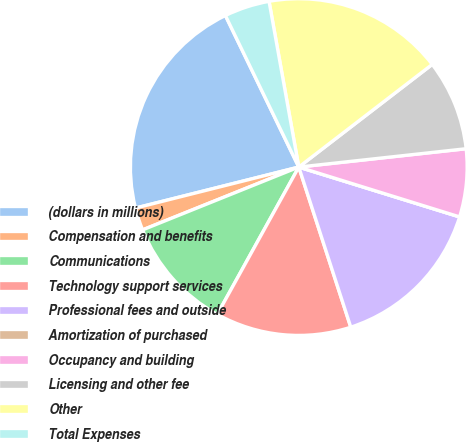Convert chart to OTSL. <chart><loc_0><loc_0><loc_500><loc_500><pie_chart><fcel>(dollars in millions)<fcel>Compensation and benefits<fcel>Communications<fcel>Technology support services<fcel>Professional fees and outside<fcel>Amortization of purchased<fcel>Occupancy and building<fcel>Licensing and other fee<fcel>Other<fcel>Total Expenses<nl><fcel>21.74%<fcel>2.17%<fcel>10.87%<fcel>13.04%<fcel>15.22%<fcel>0.0%<fcel>6.52%<fcel>8.7%<fcel>17.39%<fcel>4.35%<nl></chart> 